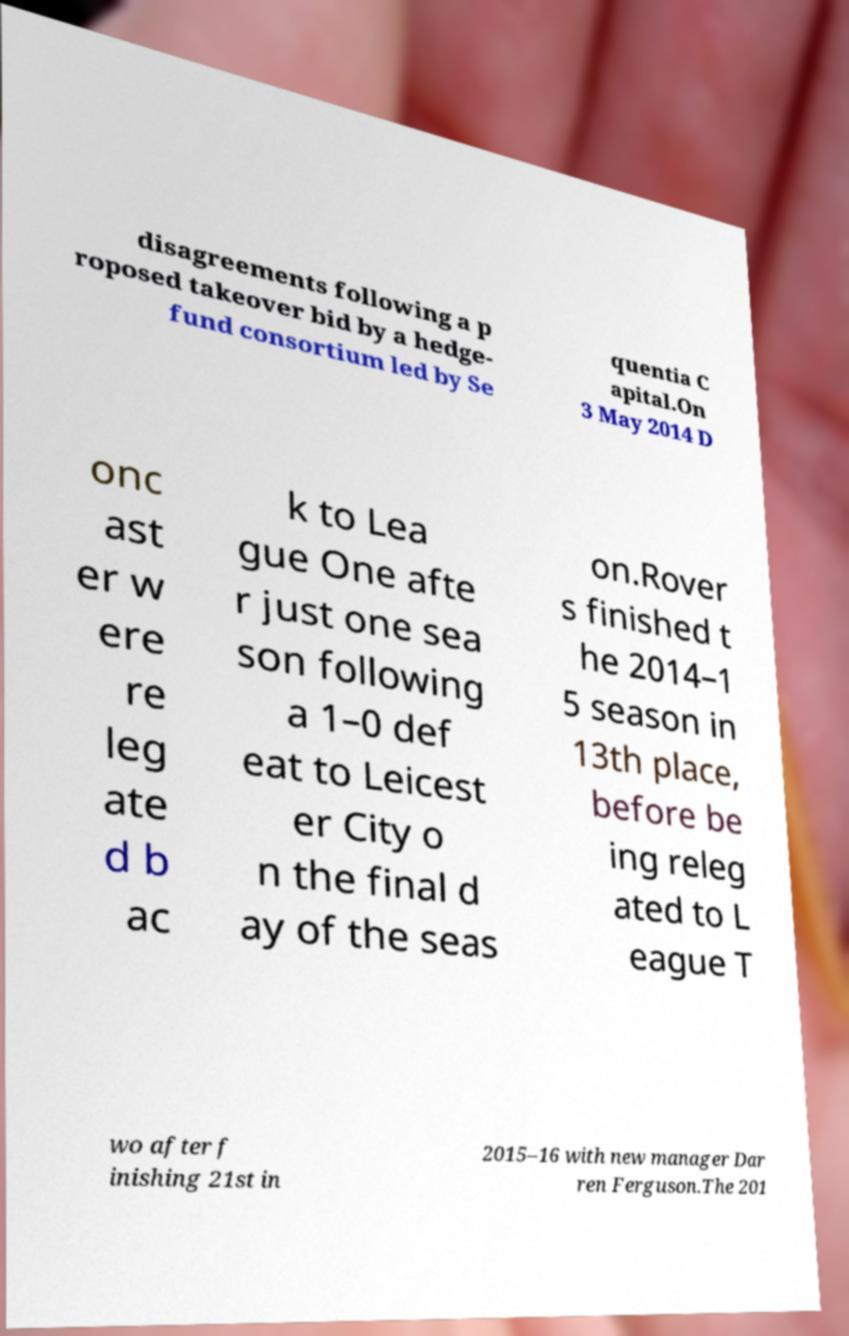Please read and relay the text visible in this image. What does it say? disagreements following a p roposed takeover bid by a hedge- fund consortium led by Se quentia C apital.On 3 May 2014 D onc ast er w ere re leg ate d b ac k to Lea gue One afte r just one sea son following a 1–0 def eat to Leicest er City o n the final d ay of the seas on.Rover s finished t he 2014–1 5 season in 13th place, before be ing releg ated to L eague T wo after f inishing 21st in 2015–16 with new manager Dar ren Ferguson.The 201 